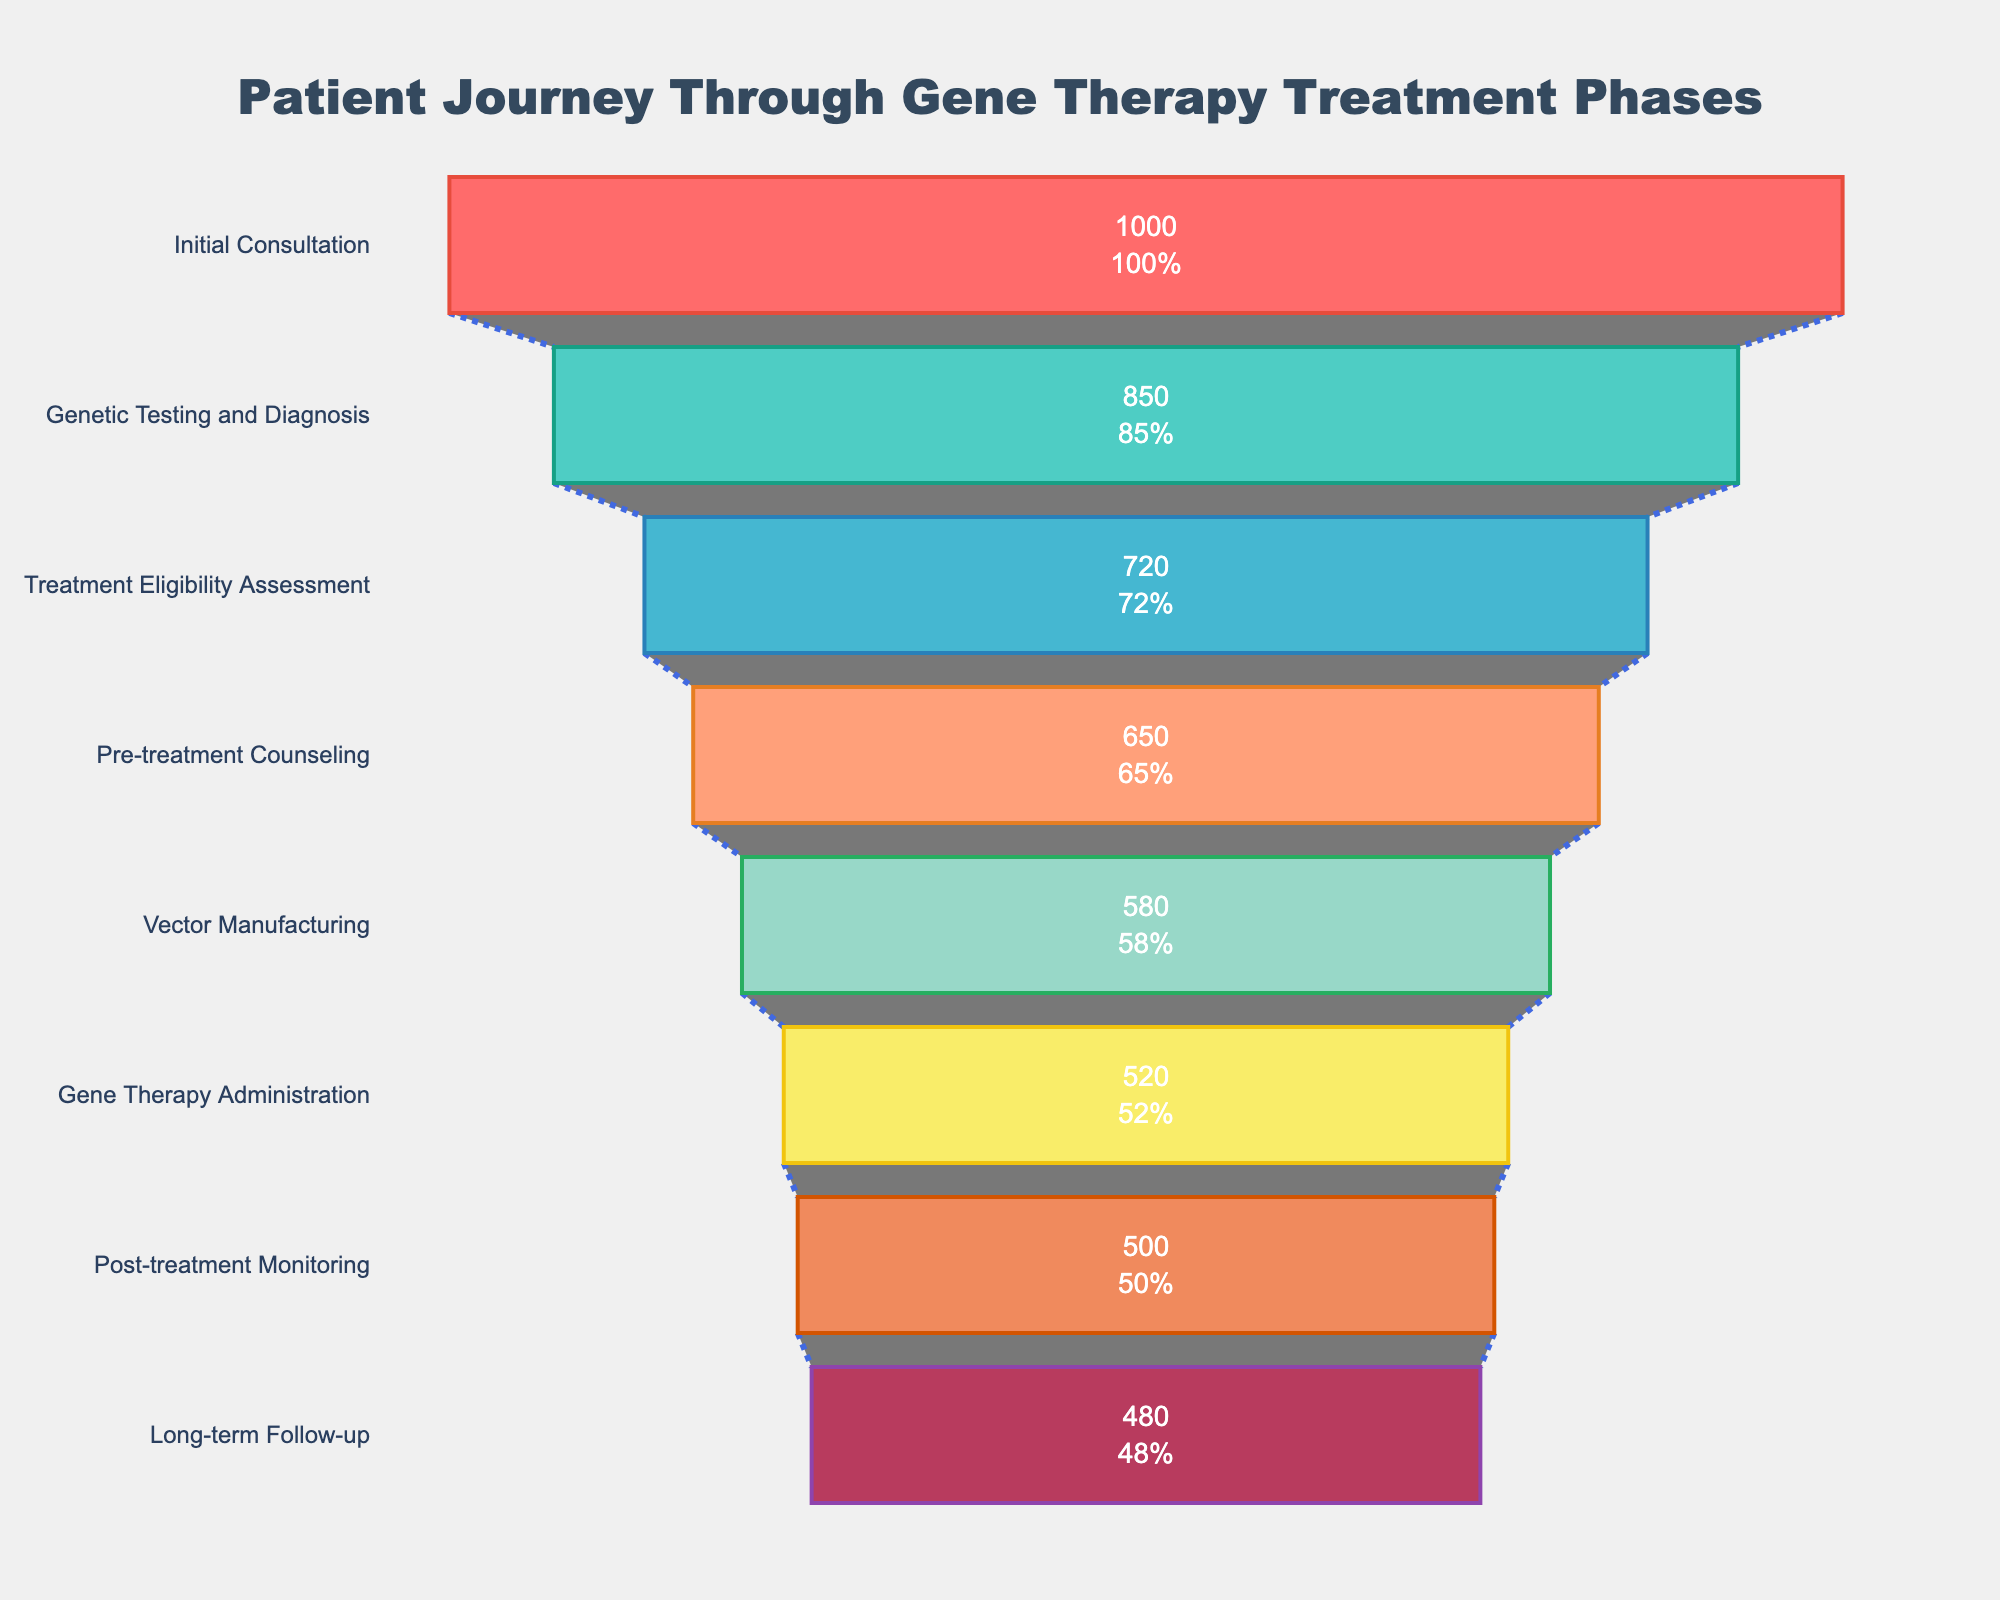how many patients are there at the initial consultation stage? The initial consultation stage is labeled with a number of patients. By looking at the figure, we can see the number of patients is 1000.
Answer: 1000 how many stages are present in the funnel chart? By counting the number of stages listed on the y-axis of the figure, we see there are eight stages.
Answer: 8 what is the percentage of patients that proceed from genetic testing and diagnosis to treatment eligibility assessment? The number of patients at the genetic testing and diagnosis stage is 850, and the number at the treatment eligibility assessment stage is 720. To find the percentage, we use the formula (720/850) * 100, which is approximately 84.71%.
Answer: 84.71% which stage has the greatest drop in the number of patients from the previous stage? By looking at the patient numbers in consecutive stages and calculating the differences, we see the largest drop is from the initial consultation (1000) to genetic testing and diagnosis (850), a drop of 150 patients.
Answer: Initial Consultation to Genetic Testing and Diagnosis how many more patients are in the initial consultation stage compared to the gene therapy administration stage? The initial consultation stage has 1000 patients, and the gene therapy administration stage has 520 patients. The difference is 1000 - 520 = 480 patients.
Answer: 480 what is the title of the funnel chart? The title of the funnel chart is displayed at the top. It reads "Patient Journey Through Gene Therapy Treatment Phases".
Answer: Patient Journey Through Gene Therapy Treatment Phases how many patients undergo pre-treatment counseling? The stage labeled "Pre-treatment Counseling" shows the number of patients. From the figure, it is 650.
Answer: 650 what proportion of the initial 1000 patients reach the long-term follow-up stage? The number of patients in the initial consultation stage is 1000, and the number of patients in the long-term follow-up stage is 480. The proportion is calculated as 480 / 1000, which is 0.48 or 48%.
Answer: 48% which stage follows vector manufacturing? By looking at the sequence of stages on the y-axis, it shows that the stage following vector manufacturing (580 patients) is gene therapy administration (520 patients).
Answer: Gene Therapy Administration 